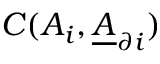<formula> <loc_0><loc_0><loc_500><loc_500>C ( A _ { i } , \underline { A } _ { \partial i } )</formula> 